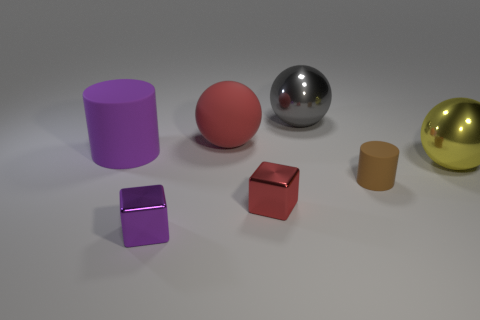Is the color of the matte ball the same as the small shiny block that is on the right side of the purple metal thing?
Ensure brevity in your answer.  Yes. What is the shape of the rubber object to the left of the red ball?
Offer a terse response. Cylinder. What number of other objects are there of the same material as the brown object?
Your answer should be very brief. 2. What material is the large gray thing?
Your answer should be compact. Metal. What number of big things are metal cubes or gray metallic objects?
Give a very brief answer. 1. How many large purple matte cylinders are behind the gray ball?
Your answer should be compact. 0. Are there any metallic blocks that have the same color as the large rubber cylinder?
Your response must be concise. Yes. The brown matte thing that is the same size as the red metallic block is what shape?
Your answer should be very brief. Cylinder. How many green things are either large rubber balls or tiny metal cubes?
Your answer should be very brief. 0. What number of red shiny objects have the same size as the purple block?
Your answer should be very brief. 1. 